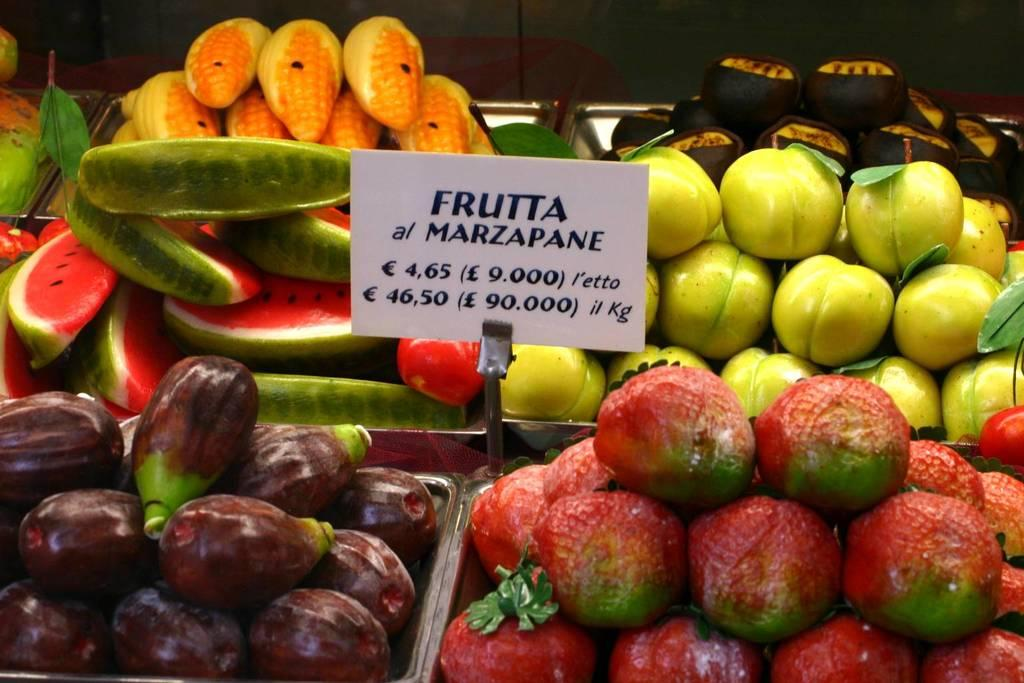What types of food items are visible in the image? There are fruits and vegetables in the image. How are the fruits and vegetables arranged in the image? The fruits and vegetables are in baskets. What additional item can be seen in the image? There is a rate card present in the image. What is the square-shaped attraction in the image? There is no square-shaped attraction present in the image. 